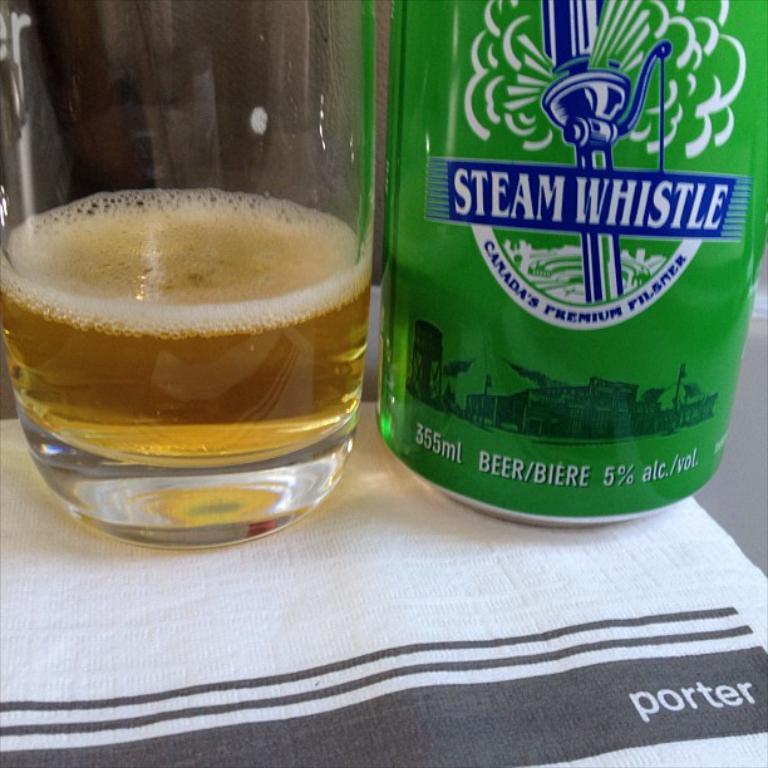How much alcohol by volume does this beer have?
Keep it short and to the point. 5%. What country is this beer from?
Provide a succinct answer. Canada. 